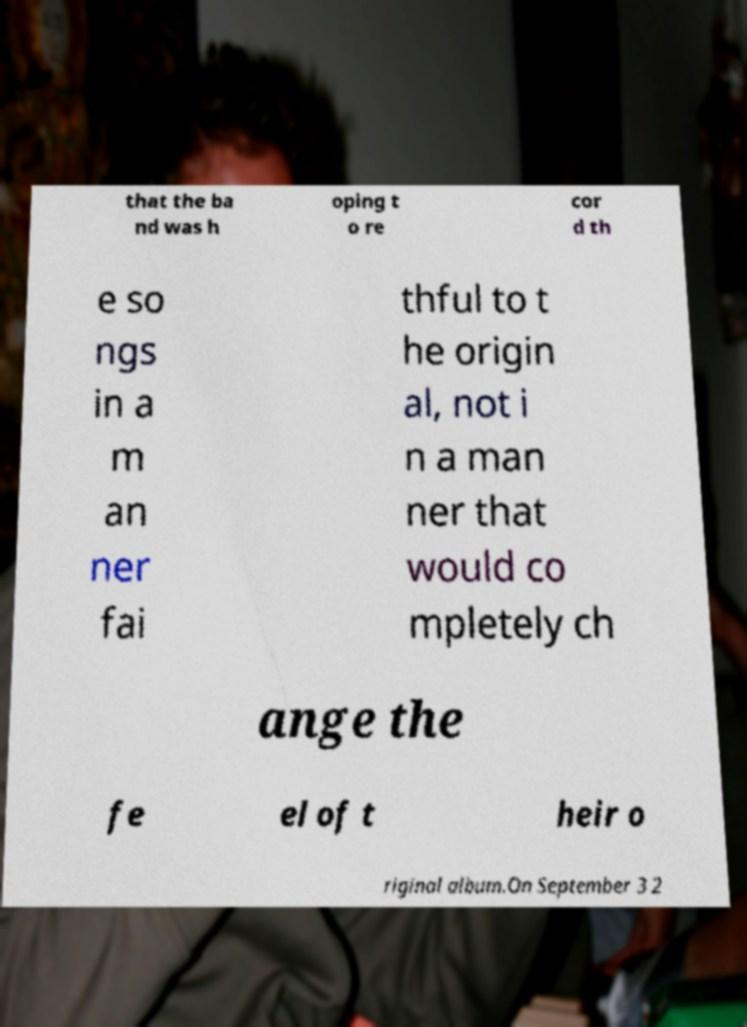Could you extract and type out the text from this image? that the ba nd was h oping t o re cor d th e so ngs in a m an ner fai thful to t he origin al, not i n a man ner that would co mpletely ch ange the fe el of t heir o riginal album.On September 3 2 